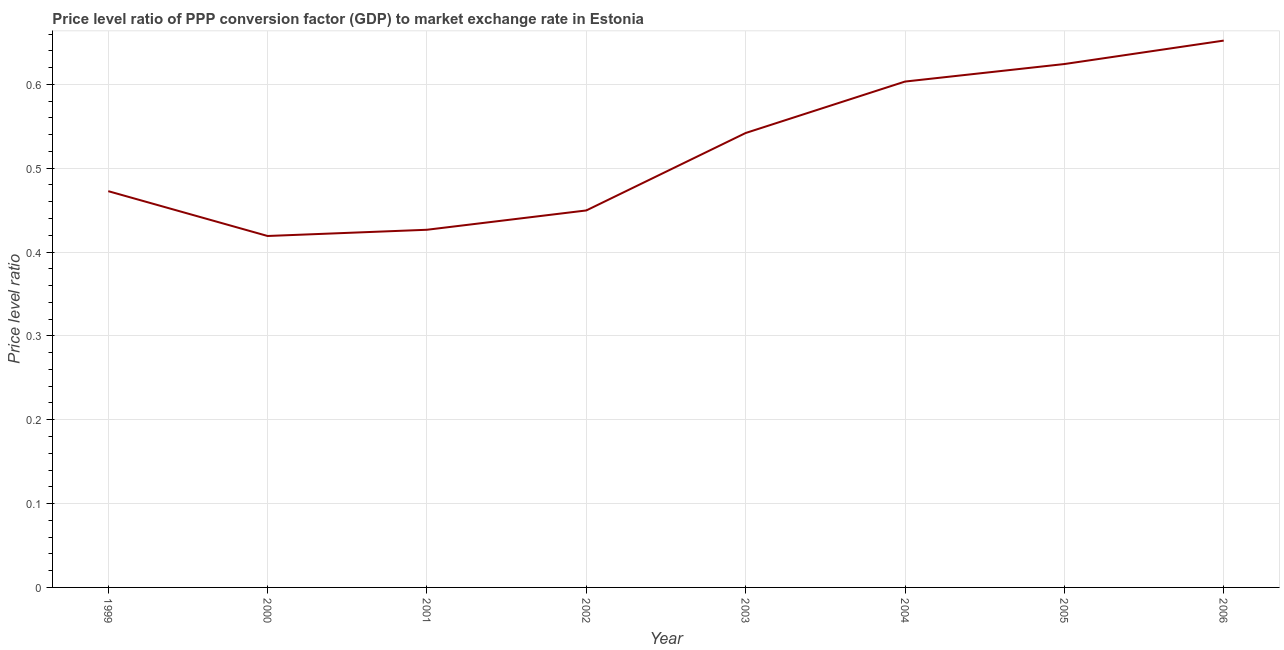What is the price level ratio in 2006?
Ensure brevity in your answer.  0.65. Across all years, what is the maximum price level ratio?
Your answer should be very brief. 0.65. Across all years, what is the minimum price level ratio?
Give a very brief answer. 0.42. In which year was the price level ratio maximum?
Your answer should be compact. 2006. In which year was the price level ratio minimum?
Offer a very short reply. 2000. What is the sum of the price level ratio?
Your answer should be very brief. 4.19. What is the difference between the price level ratio in 2000 and 2001?
Offer a terse response. -0.01. What is the average price level ratio per year?
Your answer should be very brief. 0.52. What is the median price level ratio?
Offer a terse response. 0.51. In how many years, is the price level ratio greater than 0.44 ?
Offer a very short reply. 6. Do a majority of the years between 2006 and 2002 (inclusive) have price level ratio greater than 0.12000000000000001 ?
Your answer should be very brief. Yes. What is the ratio of the price level ratio in 2004 to that in 2005?
Give a very brief answer. 0.97. Is the difference between the price level ratio in 2001 and 2003 greater than the difference between any two years?
Give a very brief answer. No. What is the difference between the highest and the second highest price level ratio?
Your answer should be very brief. 0.03. What is the difference between the highest and the lowest price level ratio?
Provide a succinct answer. 0.23. Does the price level ratio monotonically increase over the years?
Offer a terse response. No. How many lines are there?
Provide a short and direct response. 1. How many years are there in the graph?
Your answer should be very brief. 8. Are the values on the major ticks of Y-axis written in scientific E-notation?
Offer a terse response. No. Does the graph contain any zero values?
Offer a very short reply. No. Does the graph contain grids?
Offer a terse response. Yes. What is the title of the graph?
Ensure brevity in your answer.  Price level ratio of PPP conversion factor (GDP) to market exchange rate in Estonia. What is the label or title of the X-axis?
Keep it short and to the point. Year. What is the label or title of the Y-axis?
Keep it short and to the point. Price level ratio. What is the Price level ratio of 1999?
Make the answer very short. 0.47. What is the Price level ratio in 2000?
Ensure brevity in your answer.  0.42. What is the Price level ratio of 2001?
Your response must be concise. 0.43. What is the Price level ratio in 2002?
Provide a short and direct response. 0.45. What is the Price level ratio of 2003?
Offer a terse response. 0.54. What is the Price level ratio of 2004?
Provide a succinct answer. 0.6. What is the Price level ratio of 2005?
Provide a succinct answer. 0.62. What is the Price level ratio of 2006?
Offer a terse response. 0.65. What is the difference between the Price level ratio in 1999 and 2000?
Provide a short and direct response. 0.05. What is the difference between the Price level ratio in 1999 and 2001?
Offer a terse response. 0.05. What is the difference between the Price level ratio in 1999 and 2002?
Your answer should be very brief. 0.02. What is the difference between the Price level ratio in 1999 and 2003?
Provide a succinct answer. -0.07. What is the difference between the Price level ratio in 1999 and 2004?
Your response must be concise. -0.13. What is the difference between the Price level ratio in 1999 and 2005?
Make the answer very short. -0.15. What is the difference between the Price level ratio in 1999 and 2006?
Provide a short and direct response. -0.18. What is the difference between the Price level ratio in 2000 and 2001?
Make the answer very short. -0.01. What is the difference between the Price level ratio in 2000 and 2002?
Your response must be concise. -0.03. What is the difference between the Price level ratio in 2000 and 2003?
Your answer should be very brief. -0.12. What is the difference between the Price level ratio in 2000 and 2004?
Your answer should be very brief. -0.18. What is the difference between the Price level ratio in 2000 and 2005?
Give a very brief answer. -0.21. What is the difference between the Price level ratio in 2000 and 2006?
Provide a short and direct response. -0.23. What is the difference between the Price level ratio in 2001 and 2002?
Ensure brevity in your answer.  -0.02. What is the difference between the Price level ratio in 2001 and 2003?
Offer a terse response. -0.12. What is the difference between the Price level ratio in 2001 and 2004?
Keep it short and to the point. -0.18. What is the difference between the Price level ratio in 2001 and 2005?
Your answer should be very brief. -0.2. What is the difference between the Price level ratio in 2001 and 2006?
Your response must be concise. -0.23. What is the difference between the Price level ratio in 2002 and 2003?
Offer a very short reply. -0.09. What is the difference between the Price level ratio in 2002 and 2004?
Your response must be concise. -0.15. What is the difference between the Price level ratio in 2002 and 2005?
Keep it short and to the point. -0.17. What is the difference between the Price level ratio in 2002 and 2006?
Ensure brevity in your answer.  -0.2. What is the difference between the Price level ratio in 2003 and 2004?
Offer a terse response. -0.06. What is the difference between the Price level ratio in 2003 and 2005?
Ensure brevity in your answer.  -0.08. What is the difference between the Price level ratio in 2003 and 2006?
Keep it short and to the point. -0.11. What is the difference between the Price level ratio in 2004 and 2005?
Your answer should be very brief. -0.02. What is the difference between the Price level ratio in 2004 and 2006?
Offer a terse response. -0.05. What is the difference between the Price level ratio in 2005 and 2006?
Keep it short and to the point. -0.03. What is the ratio of the Price level ratio in 1999 to that in 2000?
Keep it short and to the point. 1.13. What is the ratio of the Price level ratio in 1999 to that in 2001?
Your answer should be compact. 1.11. What is the ratio of the Price level ratio in 1999 to that in 2002?
Provide a succinct answer. 1.05. What is the ratio of the Price level ratio in 1999 to that in 2003?
Your answer should be very brief. 0.87. What is the ratio of the Price level ratio in 1999 to that in 2004?
Your answer should be very brief. 0.78. What is the ratio of the Price level ratio in 1999 to that in 2005?
Ensure brevity in your answer.  0.76. What is the ratio of the Price level ratio in 1999 to that in 2006?
Give a very brief answer. 0.72. What is the ratio of the Price level ratio in 2000 to that in 2001?
Ensure brevity in your answer.  0.98. What is the ratio of the Price level ratio in 2000 to that in 2002?
Provide a short and direct response. 0.93. What is the ratio of the Price level ratio in 2000 to that in 2003?
Offer a very short reply. 0.77. What is the ratio of the Price level ratio in 2000 to that in 2004?
Ensure brevity in your answer.  0.69. What is the ratio of the Price level ratio in 2000 to that in 2005?
Provide a succinct answer. 0.67. What is the ratio of the Price level ratio in 2000 to that in 2006?
Provide a succinct answer. 0.64. What is the ratio of the Price level ratio in 2001 to that in 2002?
Your answer should be very brief. 0.95. What is the ratio of the Price level ratio in 2001 to that in 2003?
Give a very brief answer. 0.79. What is the ratio of the Price level ratio in 2001 to that in 2004?
Keep it short and to the point. 0.71. What is the ratio of the Price level ratio in 2001 to that in 2005?
Give a very brief answer. 0.68. What is the ratio of the Price level ratio in 2001 to that in 2006?
Offer a terse response. 0.65. What is the ratio of the Price level ratio in 2002 to that in 2003?
Provide a succinct answer. 0.83. What is the ratio of the Price level ratio in 2002 to that in 2004?
Give a very brief answer. 0.74. What is the ratio of the Price level ratio in 2002 to that in 2005?
Your answer should be very brief. 0.72. What is the ratio of the Price level ratio in 2002 to that in 2006?
Provide a short and direct response. 0.69. What is the ratio of the Price level ratio in 2003 to that in 2004?
Offer a terse response. 0.9. What is the ratio of the Price level ratio in 2003 to that in 2005?
Your answer should be compact. 0.87. What is the ratio of the Price level ratio in 2003 to that in 2006?
Ensure brevity in your answer.  0.83. What is the ratio of the Price level ratio in 2004 to that in 2006?
Give a very brief answer. 0.93. What is the ratio of the Price level ratio in 2005 to that in 2006?
Keep it short and to the point. 0.96. 